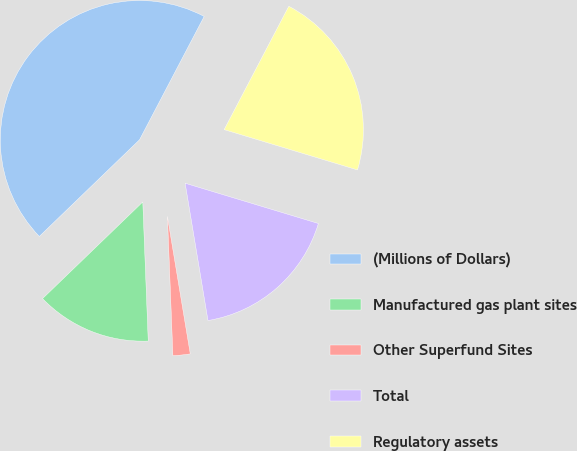<chart> <loc_0><loc_0><loc_500><loc_500><pie_chart><fcel>(Millions of Dollars)<fcel>Manufactured gas plant sites<fcel>Other Superfund Sites<fcel>Total<fcel>Regulatory assets<nl><fcel>44.89%<fcel>13.41%<fcel>2.0%<fcel>17.7%<fcel>21.99%<nl></chart> 